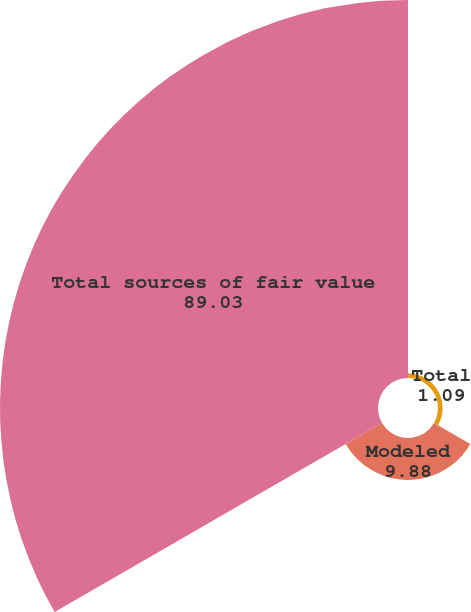Convert chart to OTSL. <chart><loc_0><loc_0><loc_500><loc_500><pie_chart><fcel>Total<fcel>Modeled<fcel>Total sources of fair value<nl><fcel>1.09%<fcel>9.88%<fcel>89.03%<nl></chart> 